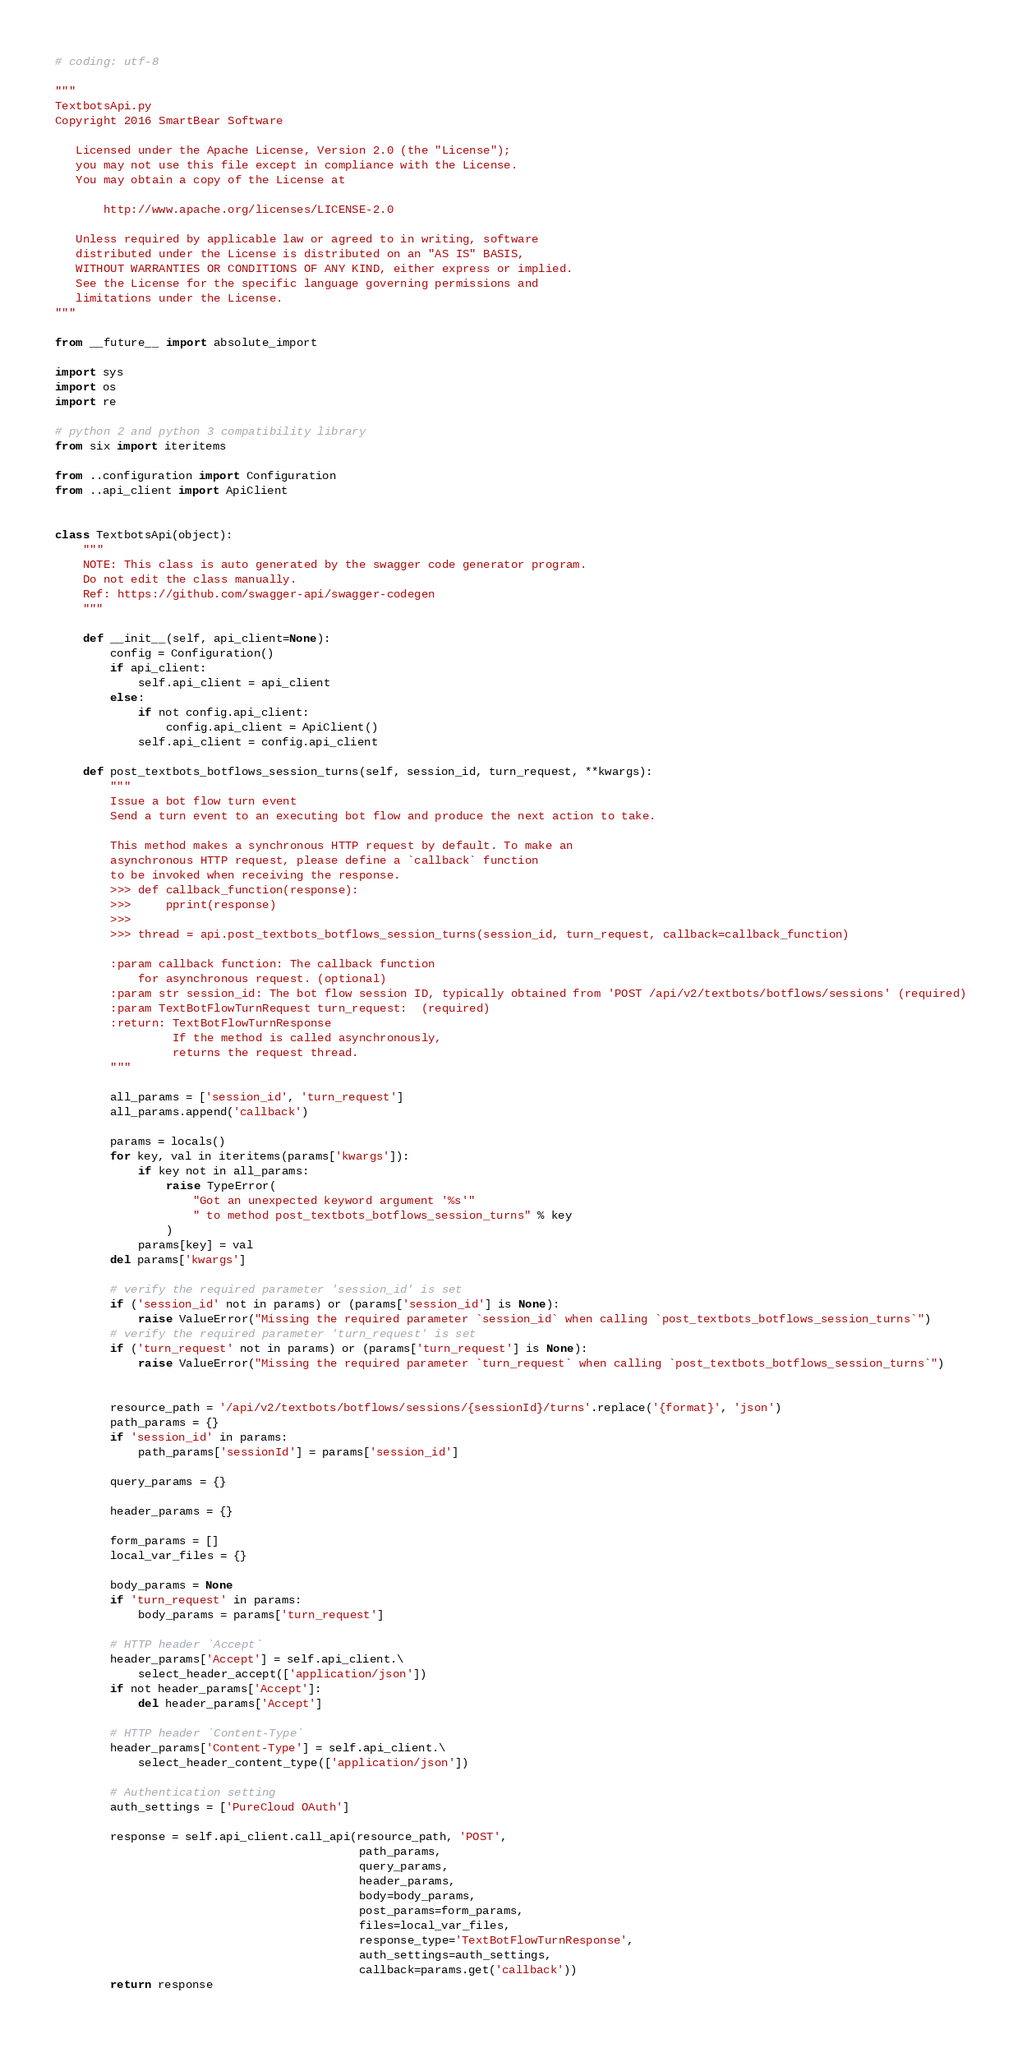<code> <loc_0><loc_0><loc_500><loc_500><_Python_># coding: utf-8

"""
TextbotsApi.py
Copyright 2016 SmartBear Software

   Licensed under the Apache License, Version 2.0 (the "License");
   you may not use this file except in compliance with the License.
   You may obtain a copy of the License at

       http://www.apache.org/licenses/LICENSE-2.0

   Unless required by applicable law or agreed to in writing, software
   distributed under the License is distributed on an "AS IS" BASIS,
   WITHOUT WARRANTIES OR CONDITIONS OF ANY KIND, either express or implied.
   See the License for the specific language governing permissions and
   limitations under the License.
"""

from __future__ import absolute_import

import sys
import os
import re

# python 2 and python 3 compatibility library
from six import iteritems

from ..configuration import Configuration
from ..api_client import ApiClient


class TextbotsApi(object):
    """
    NOTE: This class is auto generated by the swagger code generator program.
    Do not edit the class manually.
    Ref: https://github.com/swagger-api/swagger-codegen
    """

    def __init__(self, api_client=None):
        config = Configuration()
        if api_client:
            self.api_client = api_client
        else:
            if not config.api_client:
                config.api_client = ApiClient()
            self.api_client = config.api_client

    def post_textbots_botflows_session_turns(self, session_id, turn_request, **kwargs):
        """
        Issue a bot flow turn event
        Send a turn event to an executing bot flow and produce the next action to take.

        This method makes a synchronous HTTP request by default. To make an
        asynchronous HTTP request, please define a `callback` function
        to be invoked when receiving the response.
        >>> def callback_function(response):
        >>>     pprint(response)
        >>>
        >>> thread = api.post_textbots_botflows_session_turns(session_id, turn_request, callback=callback_function)

        :param callback function: The callback function
            for asynchronous request. (optional)
        :param str session_id: The bot flow session ID, typically obtained from 'POST /api/v2/textbots/botflows/sessions' (required)
        :param TextBotFlowTurnRequest turn_request:  (required)
        :return: TextBotFlowTurnResponse
                 If the method is called asynchronously,
                 returns the request thread.
        """

        all_params = ['session_id', 'turn_request']
        all_params.append('callback')

        params = locals()
        for key, val in iteritems(params['kwargs']):
            if key not in all_params:
                raise TypeError(
                    "Got an unexpected keyword argument '%s'"
                    " to method post_textbots_botflows_session_turns" % key
                )
            params[key] = val
        del params['kwargs']

        # verify the required parameter 'session_id' is set
        if ('session_id' not in params) or (params['session_id'] is None):
            raise ValueError("Missing the required parameter `session_id` when calling `post_textbots_botflows_session_turns`")
        # verify the required parameter 'turn_request' is set
        if ('turn_request' not in params) or (params['turn_request'] is None):
            raise ValueError("Missing the required parameter `turn_request` when calling `post_textbots_botflows_session_turns`")


        resource_path = '/api/v2/textbots/botflows/sessions/{sessionId}/turns'.replace('{format}', 'json')
        path_params = {}
        if 'session_id' in params:
            path_params['sessionId'] = params['session_id']

        query_params = {}

        header_params = {}

        form_params = []
        local_var_files = {}

        body_params = None
        if 'turn_request' in params:
            body_params = params['turn_request']

        # HTTP header `Accept`
        header_params['Accept'] = self.api_client.\
            select_header_accept(['application/json'])
        if not header_params['Accept']:
            del header_params['Accept']

        # HTTP header `Content-Type`
        header_params['Content-Type'] = self.api_client.\
            select_header_content_type(['application/json'])

        # Authentication setting
        auth_settings = ['PureCloud OAuth']

        response = self.api_client.call_api(resource_path, 'POST',
                                            path_params,
                                            query_params,
                                            header_params,
                                            body=body_params,
                                            post_params=form_params,
                                            files=local_var_files,
                                            response_type='TextBotFlowTurnResponse',
                                            auth_settings=auth_settings,
                                            callback=params.get('callback'))
        return response
</code> 